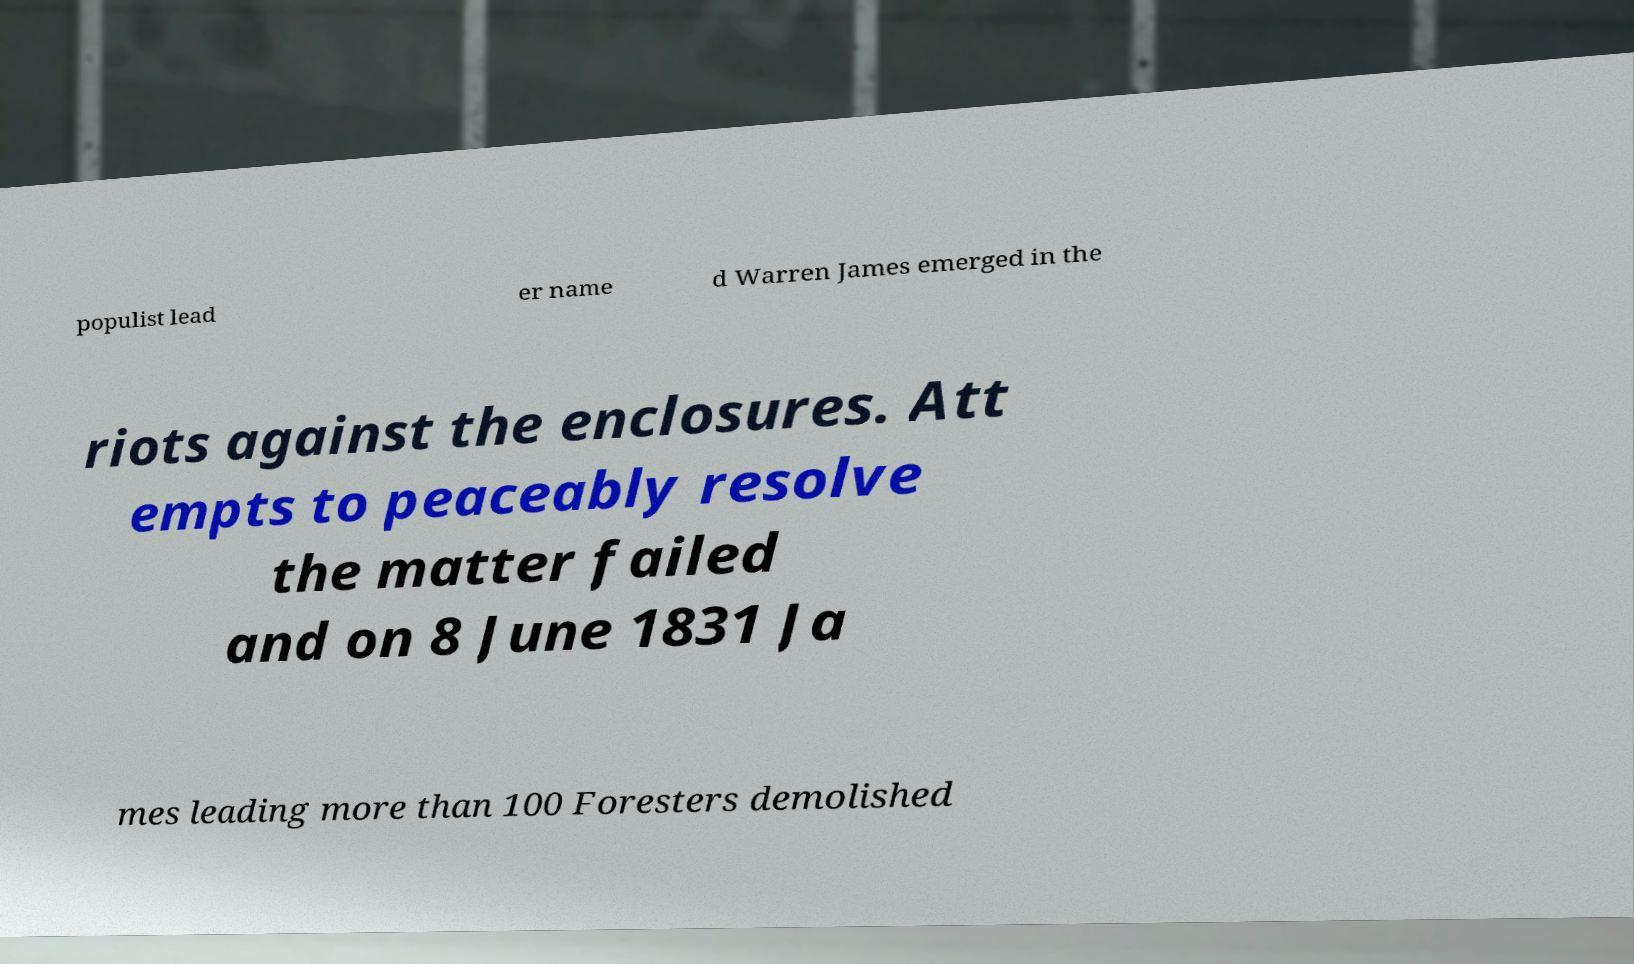Could you extract and type out the text from this image? populist lead er name d Warren James emerged in the riots against the enclosures. Att empts to peaceably resolve the matter failed and on 8 June 1831 Ja mes leading more than 100 Foresters demolished 